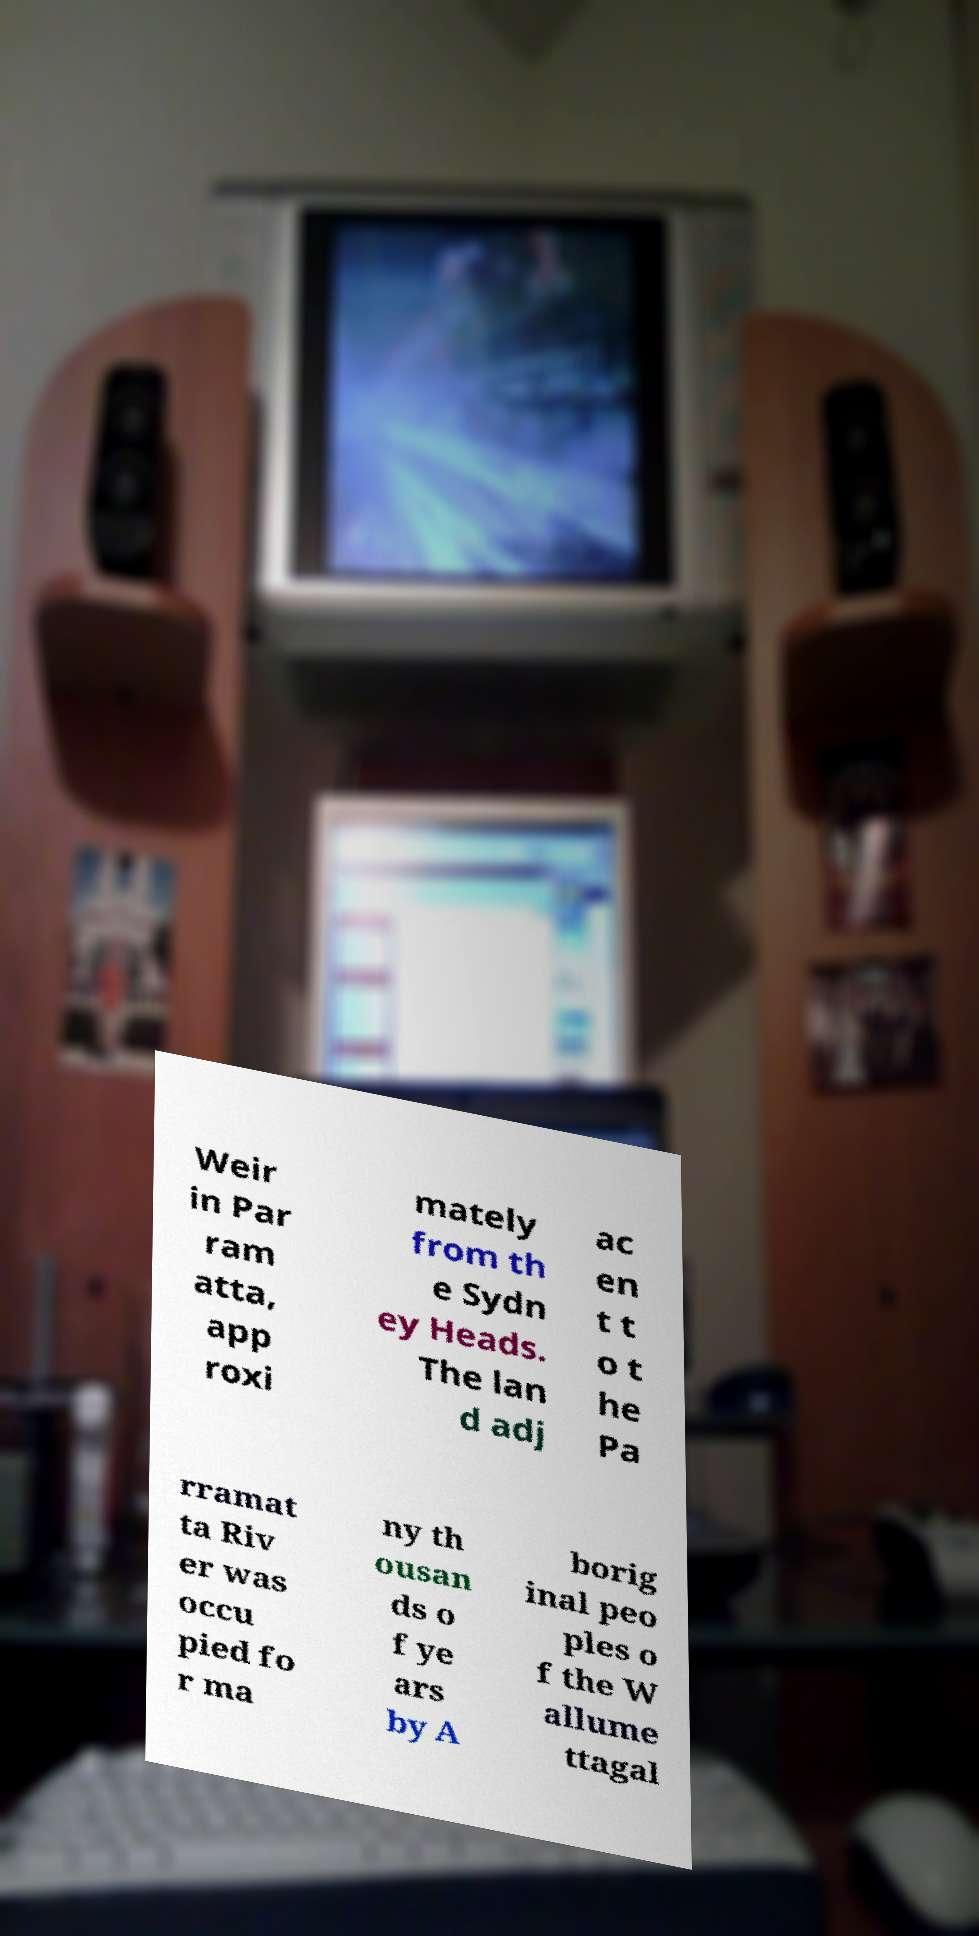I need the written content from this picture converted into text. Can you do that? Weir in Par ram atta, app roxi mately from th e Sydn ey Heads. The lan d adj ac en t t o t he Pa rramat ta Riv er was occu pied fo r ma ny th ousan ds o f ye ars by A borig inal peo ples o f the W allume ttagal 